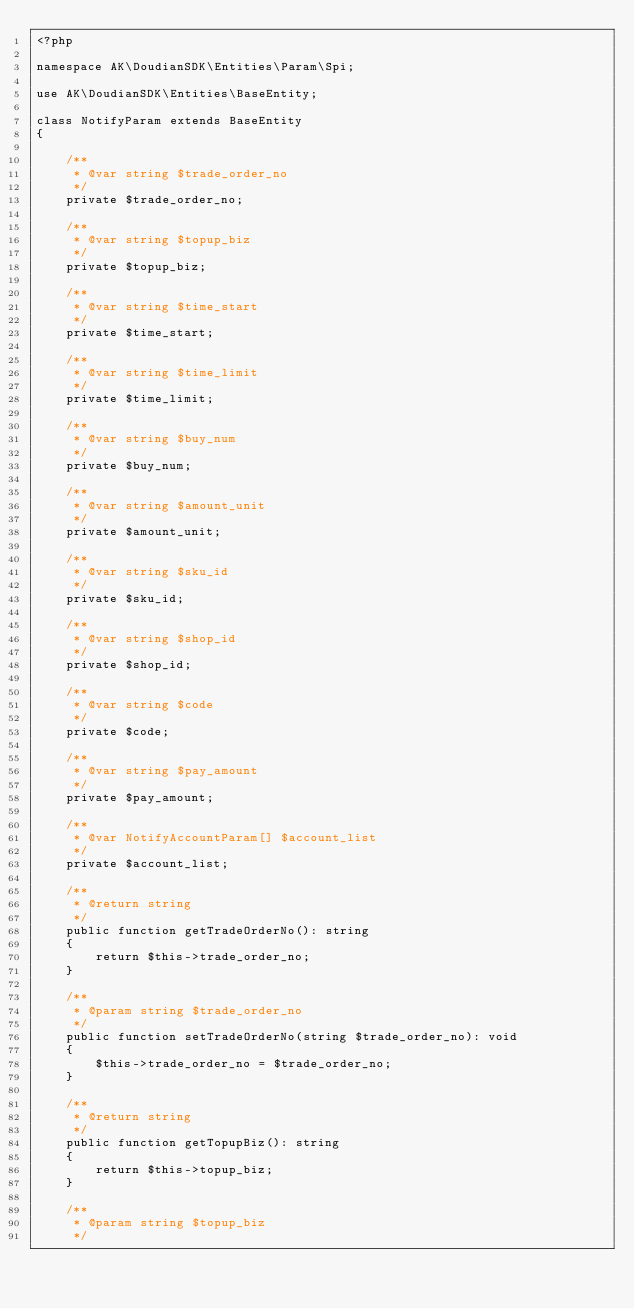<code> <loc_0><loc_0><loc_500><loc_500><_PHP_><?php

namespace AK\DoudianSDK\Entities\Param\Spi;

use AK\DoudianSDK\Entities\BaseEntity;

class NotifyParam extends BaseEntity
{

    /**
     * @var string $trade_order_no
     */
    private $trade_order_no;

    /**
     * @var string $topup_biz
     */
    private $topup_biz;

    /**
     * @var string $time_start
     */
    private $time_start;

    /**
     * @var string $time_limit
     */
    private $time_limit;

    /**
     * @var string $buy_num
     */
    private $buy_num;

    /**
     * @var string $amount_unit
     */
    private $amount_unit;

    /**
     * @var string $sku_id
     */
    private $sku_id;

    /**
     * @var string $shop_id
     */
    private $shop_id;

    /**
     * @var string $code
     */
    private $code;

    /**
     * @var string $pay_amount
     */
    private $pay_amount;

    /**
     * @var NotifyAccountParam[] $account_list
     */
    private $account_list;

    /**
     * @return string
     */
    public function getTradeOrderNo(): string
    {
        return $this->trade_order_no;
    }

    /**
     * @param string $trade_order_no
     */
    public function setTradeOrderNo(string $trade_order_no): void
    {
        $this->trade_order_no = $trade_order_no;
    }

    /**
     * @return string
     */
    public function getTopupBiz(): string
    {
        return $this->topup_biz;
    }

    /**
     * @param string $topup_biz
     */</code> 